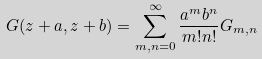<formula> <loc_0><loc_0><loc_500><loc_500>G ( z + a , z + b ) = \sum _ { m , n = 0 } ^ { \infty } \frac { a ^ { m } b ^ { n } } { m ! n ! } G _ { m , n }</formula> 